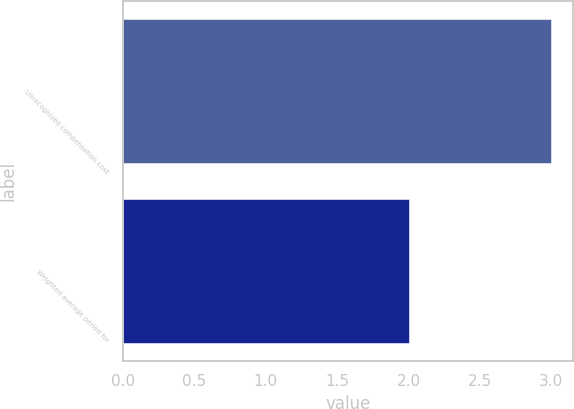Convert chart to OTSL. <chart><loc_0><loc_0><loc_500><loc_500><bar_chart><fcel>Unrecognized compensation cost<fcel>Weighted average period for<nl><fcel>3<fcel>2<nl></chart> 